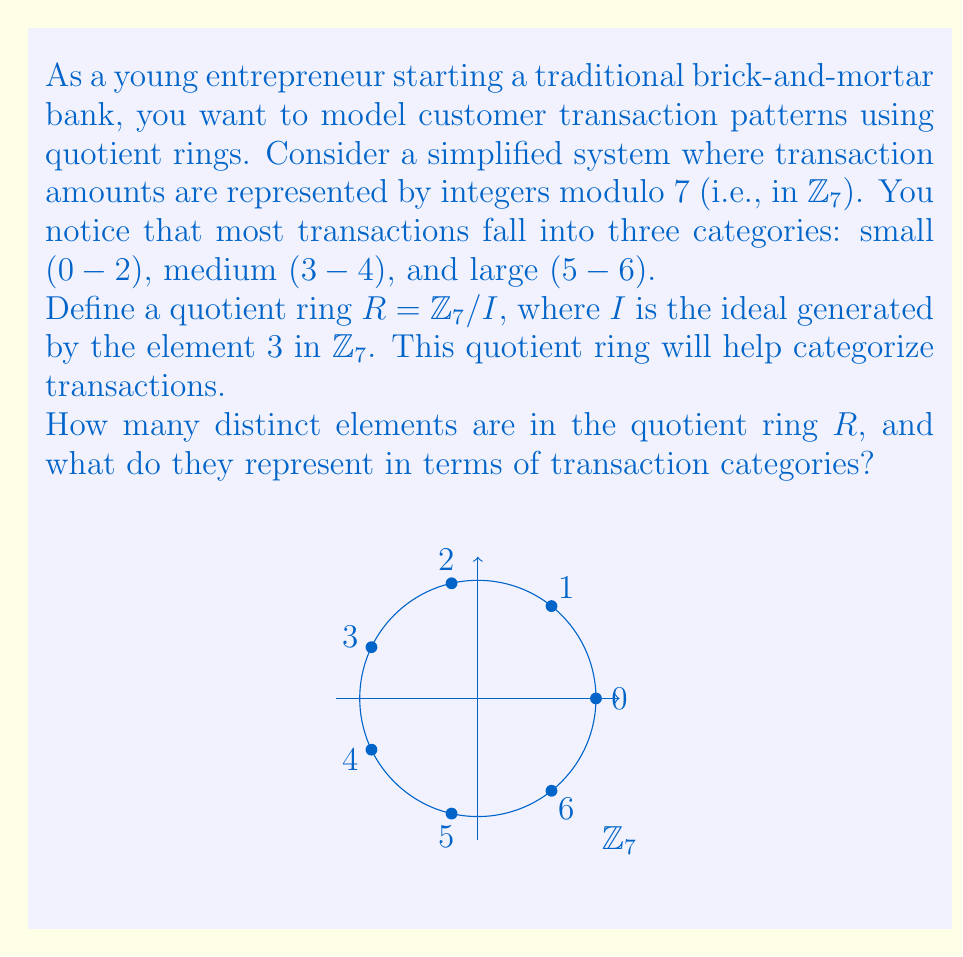Can you answer this question? Let's approach this step-by-step:

1) First, we need to understand what the ideal $I$ generated by $3$ in $\mathbb{Z}_7$ looks like:
   $I = \{0, 3, 6\}$ (because $3 \cdot 1 = 3$, $3 \cdot 2 = 6$, and $3 \cdot 3 = 2 \equiv 9 \pmod{7} \equiv 2 \pmod{7}$)

2) The quotient ring $R = \mathbb{Z}_7 / I$ consists of cosets of $I$ in $\mathbb{Z}_7$. These cosets are:
   $[0] = \{0, 3, 6\}$
   $[1] = \{1, 4\}$
   $[2] = \{2, 5\}$

3) Each element of $R$ is one of these cosets. The number of distinct elements in $R$ is equal to the number of distinct cosets, which is 3.

4) Now, let's interpret these in terms of transaction categories:
   $[0]$ represents small transactions (0-2) and some large ones (6)
   $[1]$ represents medium transactions (4) and some small ones (1)
   $[2]$ represents large transactions (5) and some small ones (2)

5) While this categorization isn't perfect (e.g., 6 is grouped with small transactions), it does provide a simplified model that reduces the 7 possible transaction amounts to 3 categories.

Thus, the quotient ring $R$ has 3 distinct elements, each representing a blend of transaction categories with an emphasis on small, medium, and large transactions respectively.
Answer: 3 elements: $[0]$, $[1]$, $[2]$, representing primarily small, medium, and large transactions respectively. 